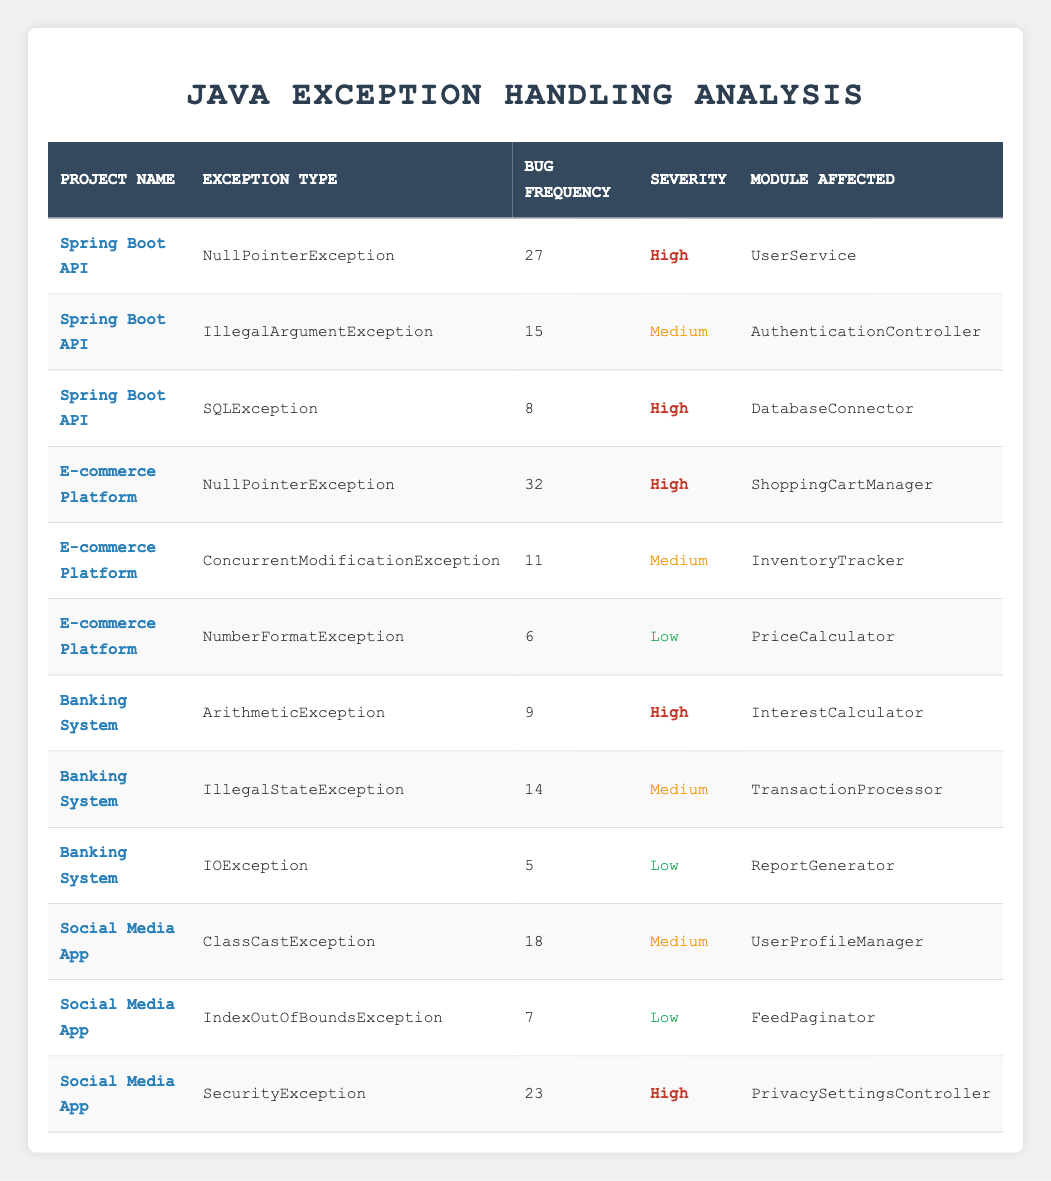What is the highest bug frequency for the E-commerce Platform? Looking at the rows for the E-commerce Platform, the highest bug frequency is for NullPointerException with a frequency of 32.
Answer: 32 Which module affected by a high severity exception has the least bug frequency? For high severity exceptions, we have UserService (27), ShoppingCartManager (32), SQL Exception (8), and InterestCalculator (9). The module with the least frequency among these is DatabaseConnector with a frequency of 8.
Answer: DatabaseConnector How many different exception types are recorded in the Banking System project? In the Banking System project, there are 3 exception types listed: ArithmeticException, IllegalStateException, and IOException. Counting these gives us a total of 3 different exception types.
Answer: 3 What is the total bug frequency for all Medium severity exceptions? The medium severity exceptions include IllegalArgumentException (15), ConcurrentModificationException (11), IllegalStateException (14), ClassCastException (18). Summing these gives us: 15 + 11 + 14 + 18 = 58.
Answer: 58 Is the sum of bug frequencies for High severity exceptions greater than that for Low severity exceptions? For High severity, the bug frequencies are: 27 (NullPointerException) + 8 (SQLException) + 32 (NullPointerException) + 9 (ArithmeticException) + 23 (SecurityException) = 99. For Low severity, the frequencies are: 6 (NumberFormatException) + 5 (IOException) + 7 (IndexOutOfBoundsException) = 18. Since 99 is greater than 18, the statement is true.
Answer: Yes Which exception type in the Spring Boot API project has the highest frequency, and how does it compare to the others? The highest bug frequency in the Spring Boot API project is from NullPointerException with a frequency of 27. Comparatively, IllegalArgumentException has 15 and SQLException has 8, which confirms that NullPointerException is significantly higher than both.
Answer: NullPointerException, 27 What is the average bug frequency for all exception types in the Social Media App? The bug frequencies for Social Media App are: 18 (ClassCastException), 7 (IndexOutOfBoundsException), and 23 (SecurityException). The total sum is 18 + 7 + 23 = 48, and there are 3 exception types; therefore, the average is 48 / 3 = 16.
Answer: 16 Which module has the lowest bug frequency and what is the exception type? The module with the lowest bug frequency is ReportGenerator with an IOException, which has a frequency of 5.
Answer: ReportGenerator, IOException How many projects have a NullPointerException listed as the exception type? There are 2 projects with a NullPointerException: Spring Boot API (27) and E-commerce Platform (32). Thus, the total is 2 projects.
Answer: 2 